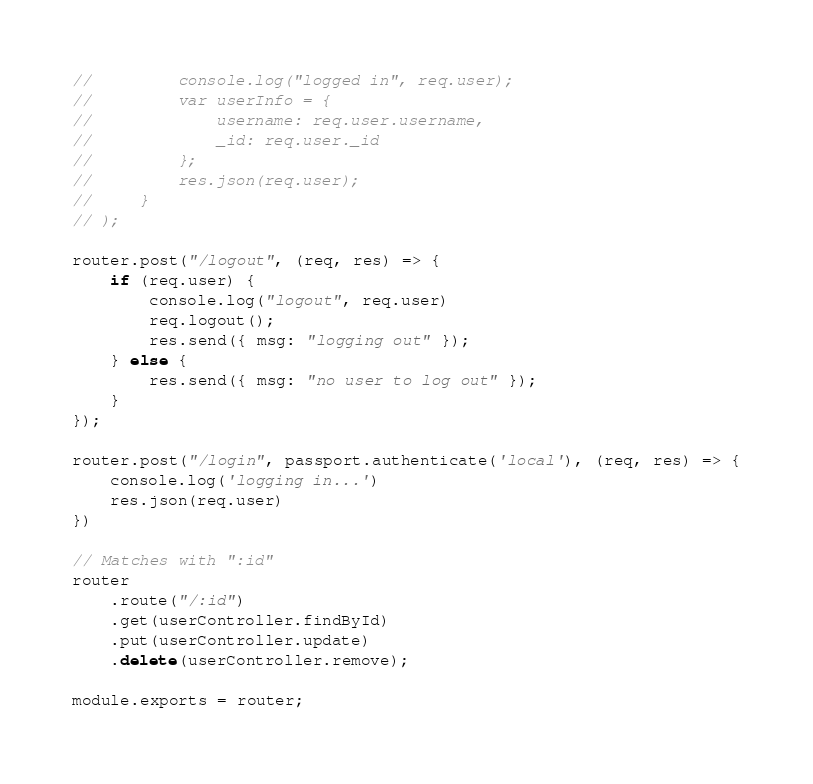<code> <loc_0><loc_0><loc_500><loc_500><_JavaScript_>//         console.log("logged in", req.user);
//         var userInfo = {
//             username: req.user.username,
//             _id: req.user._id
//         };
//         res.json(req.user);
//     }
// );

router.post("/logout", (req, res) => {
    if (req.user) {
        console.log("logout", req.user)
        req.logout();
        res.send({ msg: "logging out" });
    } else {
        res.send({ msg: "no user to log out" });
    }
});

router.post("/login", passport.authenticate('local'), (req, res) => {
    console.log('logging in...')
    res.json(req.user)
})

// Matches with ":id"
router
    .route("/:id")
    .get(userController.findById)
    .put(userController.update)
    .delete(userController.remove);

module.exports = router;
</code> 